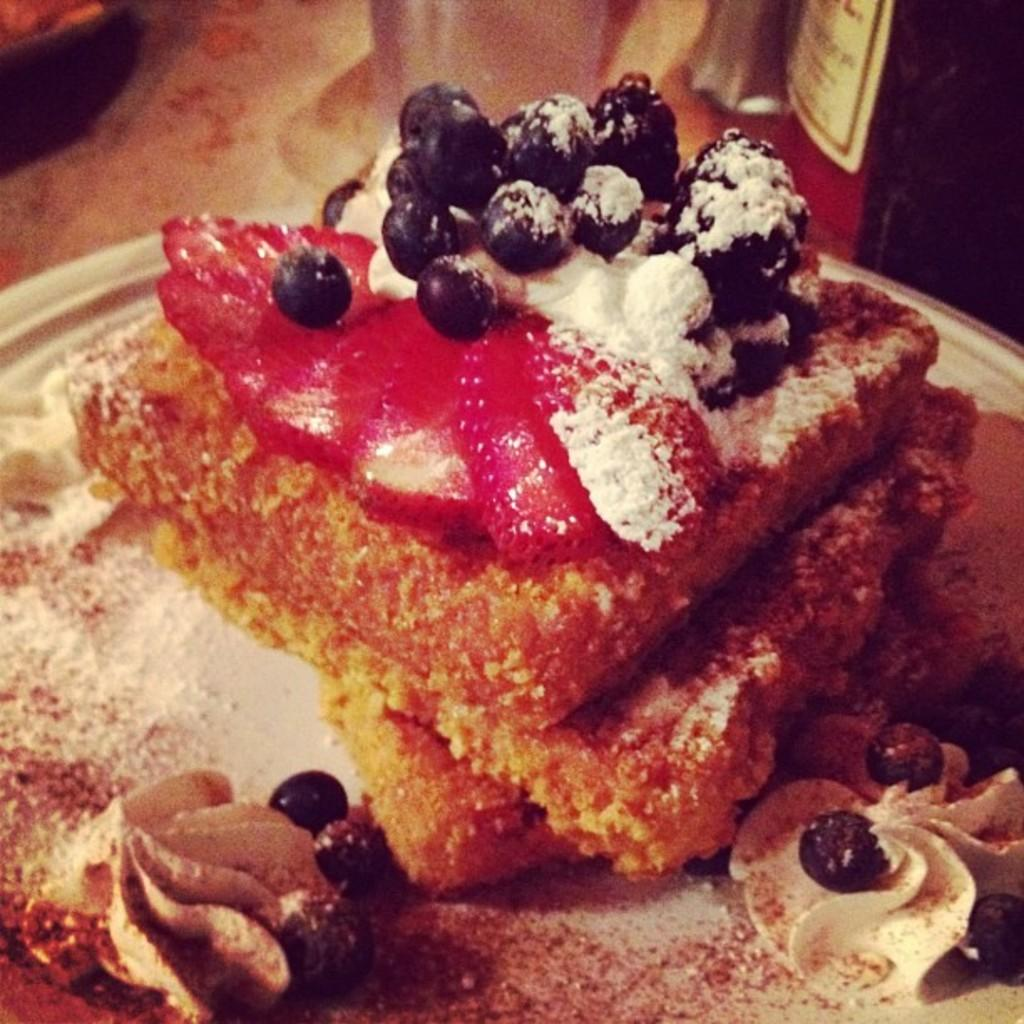What is the main subject of the image? There is a food item on a plate in the image. How many cows are visible in the image? There are no cows visible in the image; the main subject is a food item on a plate. What type of chin can be seen on the food item in the image? There is no chin present in the image, as it features a food item on a plate and not a person or animal. 